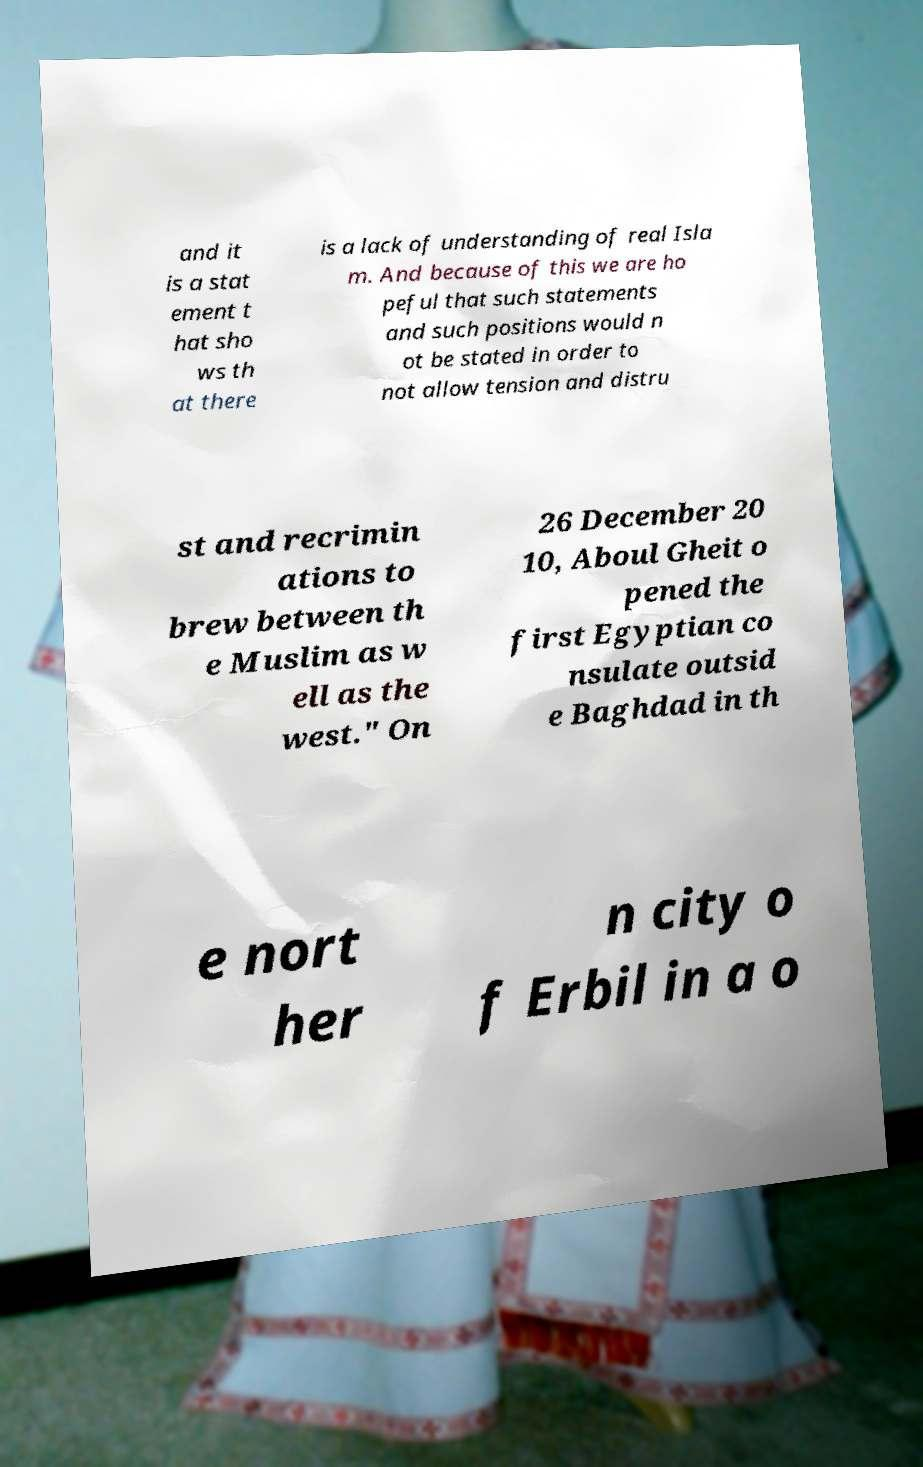Can you read and provide the text displayed in the image?This photo seems to have some interesting text. Can you extract and type it out for me? and it is a stat ement t hat sho ws th at there is a lack of understanding of real Isla m. And because of this we are ho peful that such statements and such positions would n ot be stated in order to not allow tension and distru st and recrimin ations to brew between th e Muslim as w ell as the west." On 26 December 20 10, Aboul Gheit o pened the first Egyptian co nsulate outsid e Baghdad in th e nort her n city o f Erbil in a o 